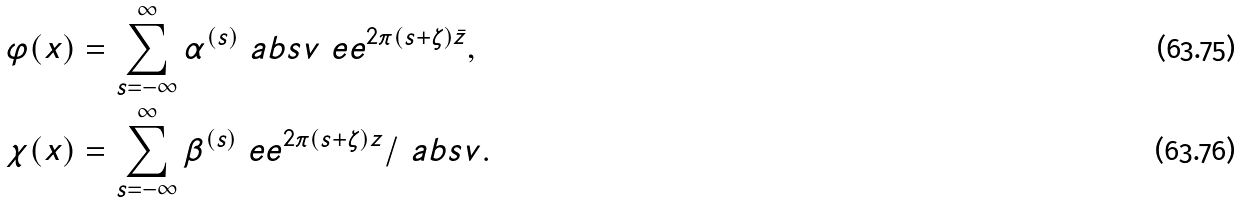<formula> <loc_0><loc_0><loc_500><loc_500>\varphi ( x ) & = \sum _ { s = - \infty } ^ { \infty } \alpha ^ { ( s ) } \ a b s { v } \ e e ^ { 2 \pi ( s + \zeta ) \bar { z } } , \\ \chi ( x ) & = \sum _ { s = - \infty } ^ { \infty } \beta ^ { ( s ) } \ e e ^ { 2 \pi ( s + \zeta ) z } / \ a b s { v } .</formula> 